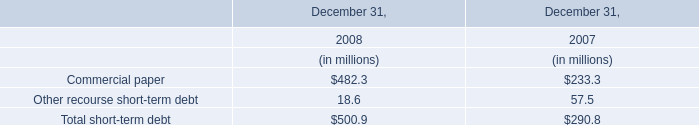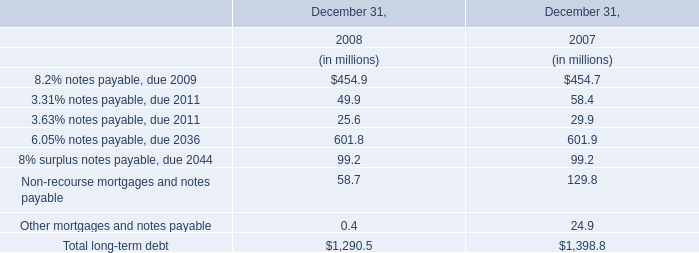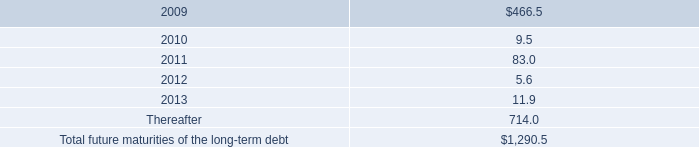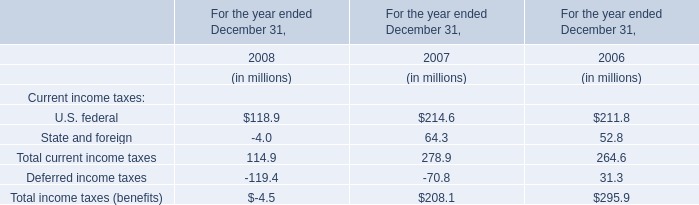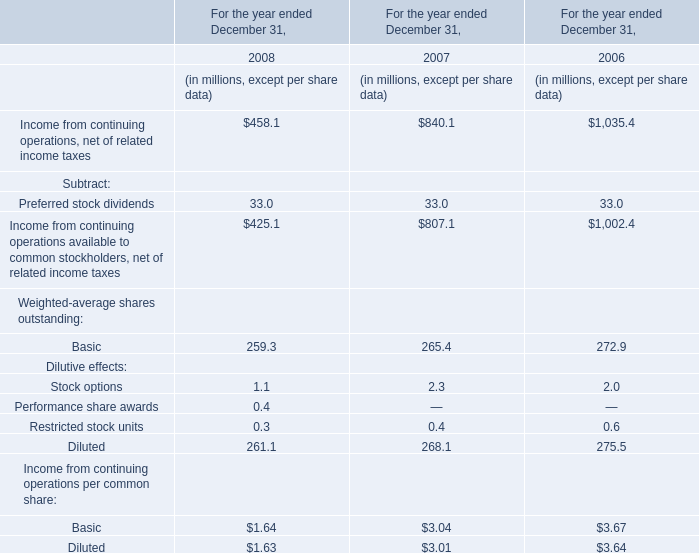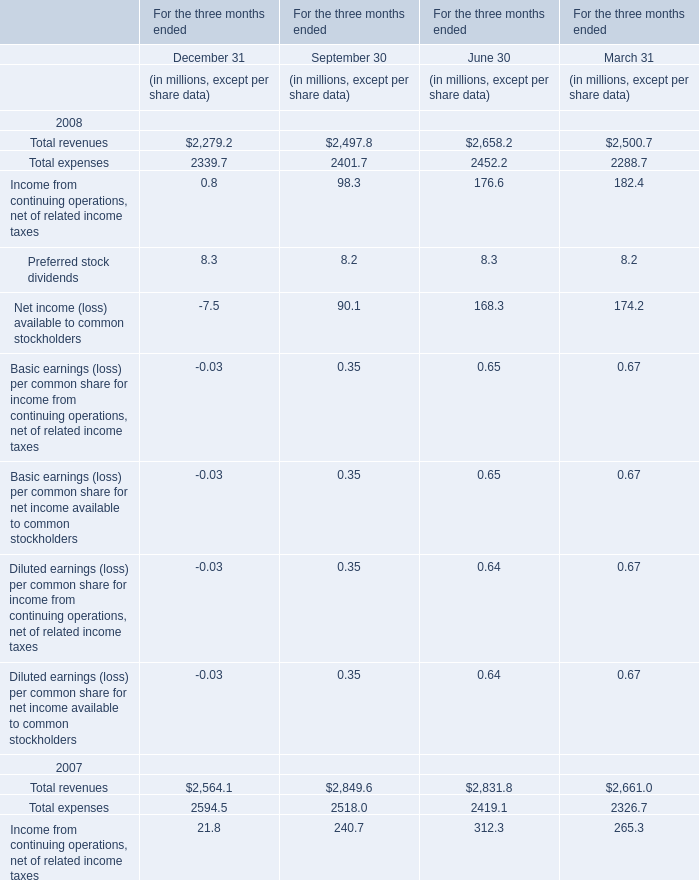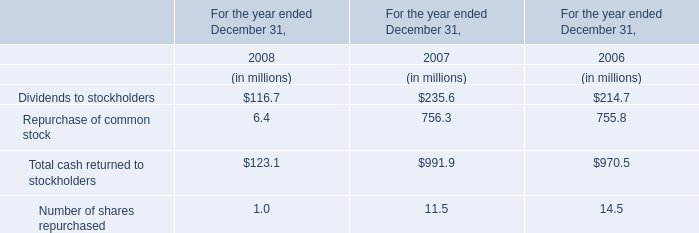What is the value of Total revenues for the three months ended September 30,2007? (in million) 
Answer: 2849.6. 